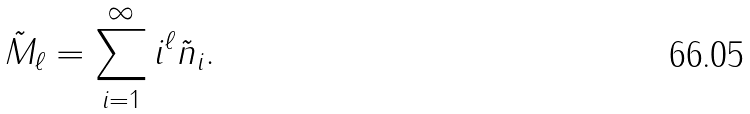<formula> <loc_0><loc_0><loc_500><loc_500>\tilde { M } _ { \ell } = \sum _ { i = 1 } ^ { \infty } i ^ { \ell } \tilde { n } _ { i } .</formula> 